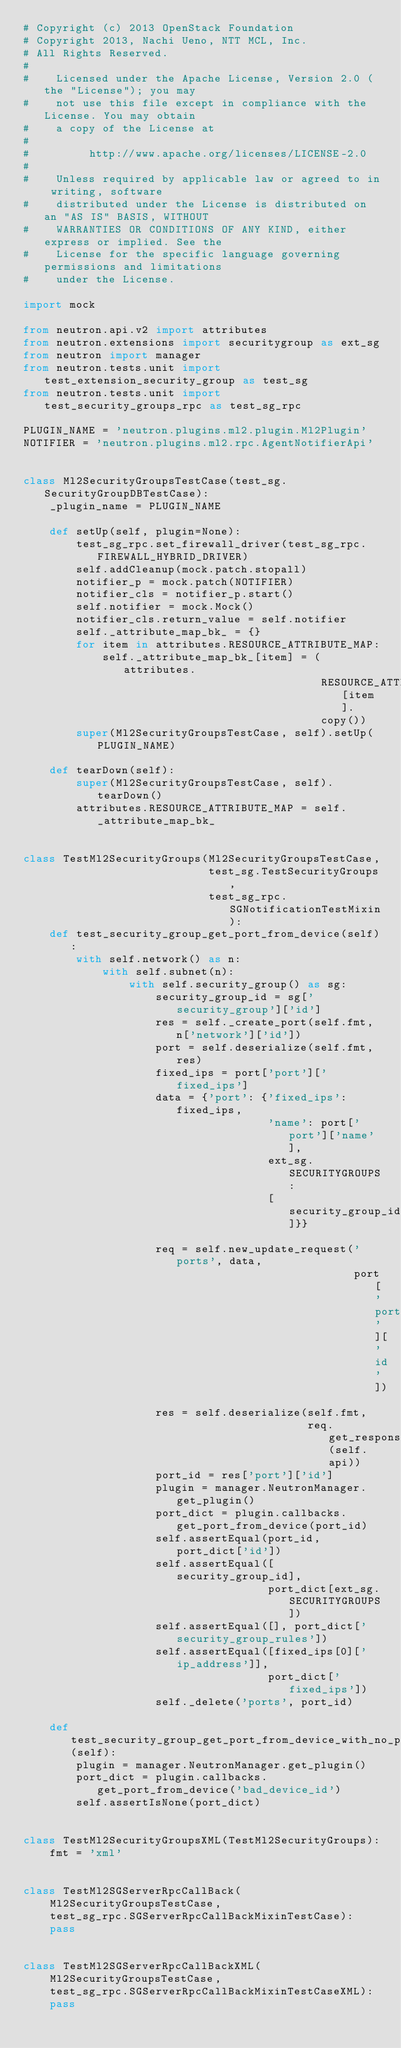<code> <loc_0><loc_0><loc_500><loc_500><_Python_># Copyright (c) 2013 OpenStack Foundation
# Copyright 2013, Nachi Ueno, NTT MCL, Inc.
# All Rights Reserved.
#
#    Licensed under the Apache License, Version 2.0 (the "License"); you may
#    not use this file except in compliance with the License. You may obtain
#    a copy of the License at
#
#         http://www.apache.org/licenses/LICENSE-2.0
#
#    Unless required by applicable law or agreed to in writing, software
#    distributed under the License is distributed on an "AS IS" BASIS, WITHOUT
#    WARRANTIES OR CONDITIONS OF ANY KIND, either express or implied. See the
#    License for the specific language governing permissions and limitations
#    under the License.

import mock

from neutron.api.v2 import attributes
from neutron.extensions import securitygroup as ext_sg
from neutron import manager
from neutron.tests.unit import test_extension_security_group as test_sg
from neutron.tests.unit import test_security_groups_rpc as test_sg_rpc

PLUGIN_NAME = 'neutron.plugins.ml2.plugin.Ml2Plugin'
NOTIFIER = 'neutron.plugins.ml2.rpc.AgentNotifierApi'


class Ml2SecurityGroupsTestCase(test_sg.SecurityGroupDBTestCase):
    _plugin_name = PLUGIN_NAME

    def setUp(self, plugin=None):
        test_sg_rpc.set_firewall_driver(test_sg_rpc.FIREWALL_HYBRID_DRIVER)
        self.addCleanup(mock.patch.stopall)
        notifier_p = mock.patch(NOTIFIER)
        notifier_cls = notifier_p.start()
        self.notifier = mock.Mock()
        notifier_cls.return_value = self.notifier
        self._attribute_map_bk_ = {}
        for item in attributes.RESOURCE_ATTRIBUTE_MAP:
            self._attribute_map_bk_[item] = (attributes.
                                             RESOURCE_ATTRIBUTE_MAP[item].
                                             copy())
        super(Ml2SecurityGroupsTestCase, self).setUp(PLUGIN_NAME)

    def tearDown(self):
        super(Ml2SecurityGroupsTestCase, self).tearDown()
        attributes.RESOURCE_ATTRIBUTE_MAP = self._attribute_map_bk_


class TestMl2SecurityGroups(Ml2SecurityGroupsTestCase,
                            test_sg.TestSecurityGroups,
                            test_sg_rpc.SGNotificationTestMixin):
    def test_security_group_get_port_from_device(self):
        with self.network() as n:
            with self.subnet(n):
                with self.security_group() as sg:
                    security_group_id = sg['security_group']['id']
                    res = self._create_port(self.fmt, n['network']['id'])
                    port = self.deserialize(self.fmt, res)
                    fixed_ips = port['port']['fixed_ips']
                    data = {'port': {'fixed_ips': fixed_ips,
                                     'name': port['port']['name'],
                                     ext_sg.SECURITYGROUPS:
                                     [security_group_id]}}

                    req = self.new_update_request('ports', data,
                                                  port['port']['id'])
                    res = self.deserialize(self.fmt,
                                           req.get_response(self.api))
                    port_id = res['port']['id']
                    plugin = manager.NeutronManager.get_plugin()
                    port_dict = plugin.callbacks.get_port_from_device(port_id)
                    self.assertEqual(port_id, port_dict['id'])
                    self.assertEqual([security_group_id],
                                     port_dict[ext_sg.SECURITYGROUPS])
                    self.assertEqual([], port_dict['security_group_rules'])
                    self.assertEqual([fixed_ips[0]['ip_address']],
                                     port_dict['fixed_ips'])
                    self._delete('ports', port_id)

    def test_security_group_get_port_from_device_with_no_port(self):
        plugin = manager.NeutronManager.get_plugin()
        port_dict = plugin.callbacks.get_port_from_device('bad_device_id')
        self.assertIsNone(port_dict)


class TestMl2SecurityGroupsXML(TestMl2SecurityGroups):
    fmt = 'xml'


class TestMl2SGServerRpcCallBack(
    Ml2SecurityGroupsTestCase,
    test_sg_rpc.SGServerRpcCallBackMixinTestCase):
    pass


class TestMl2SGServerRpcCallBackXML(
    Ml2SecurityGroupsTestCase,
    test_sg_rpc.SGServerRpcCallBackMixinTestCaseXML):
    pass
</code> 